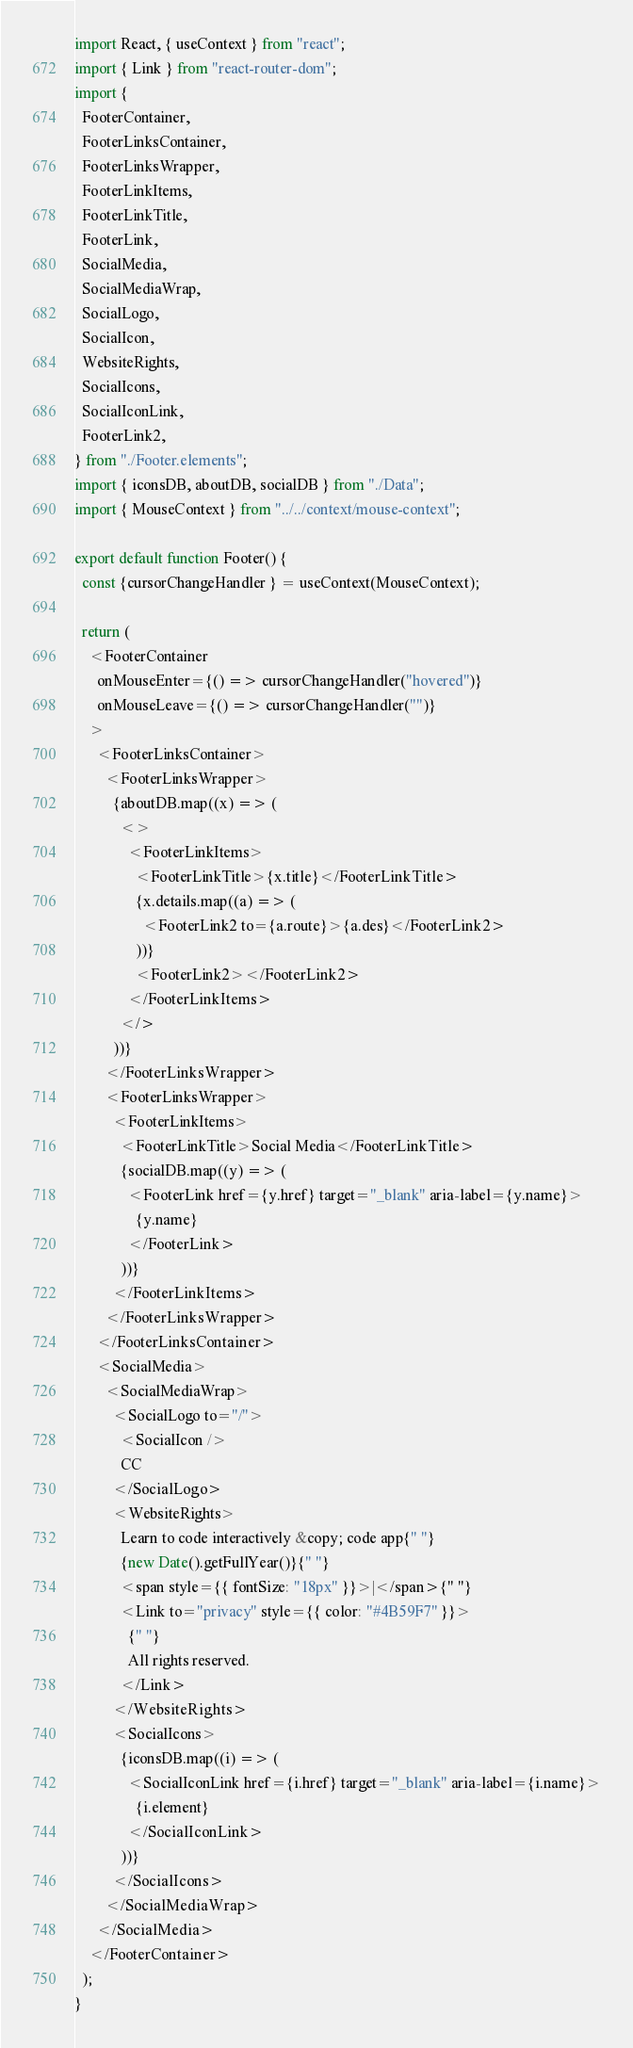Convert code to text. <code><loc_0><loc_0><loc_500><loc_500><_JavaScript_>import React, { useContext } from "react";
import { Link } from "react-router-dom";
import {
  FooterContainer,
  FooterLinksContainer,
  FooterLinksWrapper,
  FooterLinkItems,
  FooterLinkTitle,
  FooterLink,
  SocialMedia,
  SocialMediaWrap,
  SocialLogo,
  SocialIcon,
  WebsiteRights,
  SocialIcons,
  SocialIconLink,
  FooterLink2,
} from "./Footer.elements";
import { iconsDB, aboutDB, socialDB } from "./Data";
import { MouseContext } from "../../context/mouse-context";

export default function Footer() {
  const {cursorChangeHandler } = useContext(MouseContext);

  return (
    <FooterContainer
      onMouseEnter={() => cursorChangeHandler("hovered")}
      onMouseLeave={() => cursorChangeHandler("")}
    >
      <FooterLinksContainer>
        <FooterLinksWrapper>
          {aboutDB.map((x) => (
            <>
              <FooterLinkItems>
                <FooterLinkTitle>{x.title}</FooterLinkTitle>
                {x.details.map((a) => (
                  <FooterLink2 to={a.route}>{a.des}</FooterLink2>
                ))}
                <FooterLink2></FooterLink2>
              </FooterLinkItems>
            </>
          ))}
        </FooterLinksWrapper>
        <FooterLinksWrapper>
          <FooterLinkItems>
            <FooterLinkTitle>Social Media</FooterLinkTitle>
            {socialDB.map((y) => (
              <FooterLink href={y.href} target="_blank" aria-label={y.name}>
                {y.name}
              </FooterLink>
            ))}
          </FooterLinkItems>
        </FooterLinksWrapper>
      </FooterLinksContainer>
      <SocialMedia>
        <SocialMediaWrap>
          <SocialLogo to="/">
            <SocialIcon />
            CC
          </SocialLogo>
          <WebsiteRights>
            Learn to code interactively &copy; code app{" "}
            {new Date().getFullYear()}{" "}
            <span style={{ fontSize: "18px" }}>|</span>{" "}
            <Link to="privacy" style={{ color: "#4B59F7" }}>
              {" "}
              All rights reserved.
            </Link>
          </WebsiteRights>
          <SocialIcons>
            {iconsDB.map((i) => (
              <SocialIconLink href={i.href} target="_blank" aria-label={i.name}>
                {i.element}
              </SocialIconLink>
            ))}
          </SocialIcons>
        </SocialMediaWrap>
      </SocialMedia>
    </FooterContainer>
  );
}
</code> 